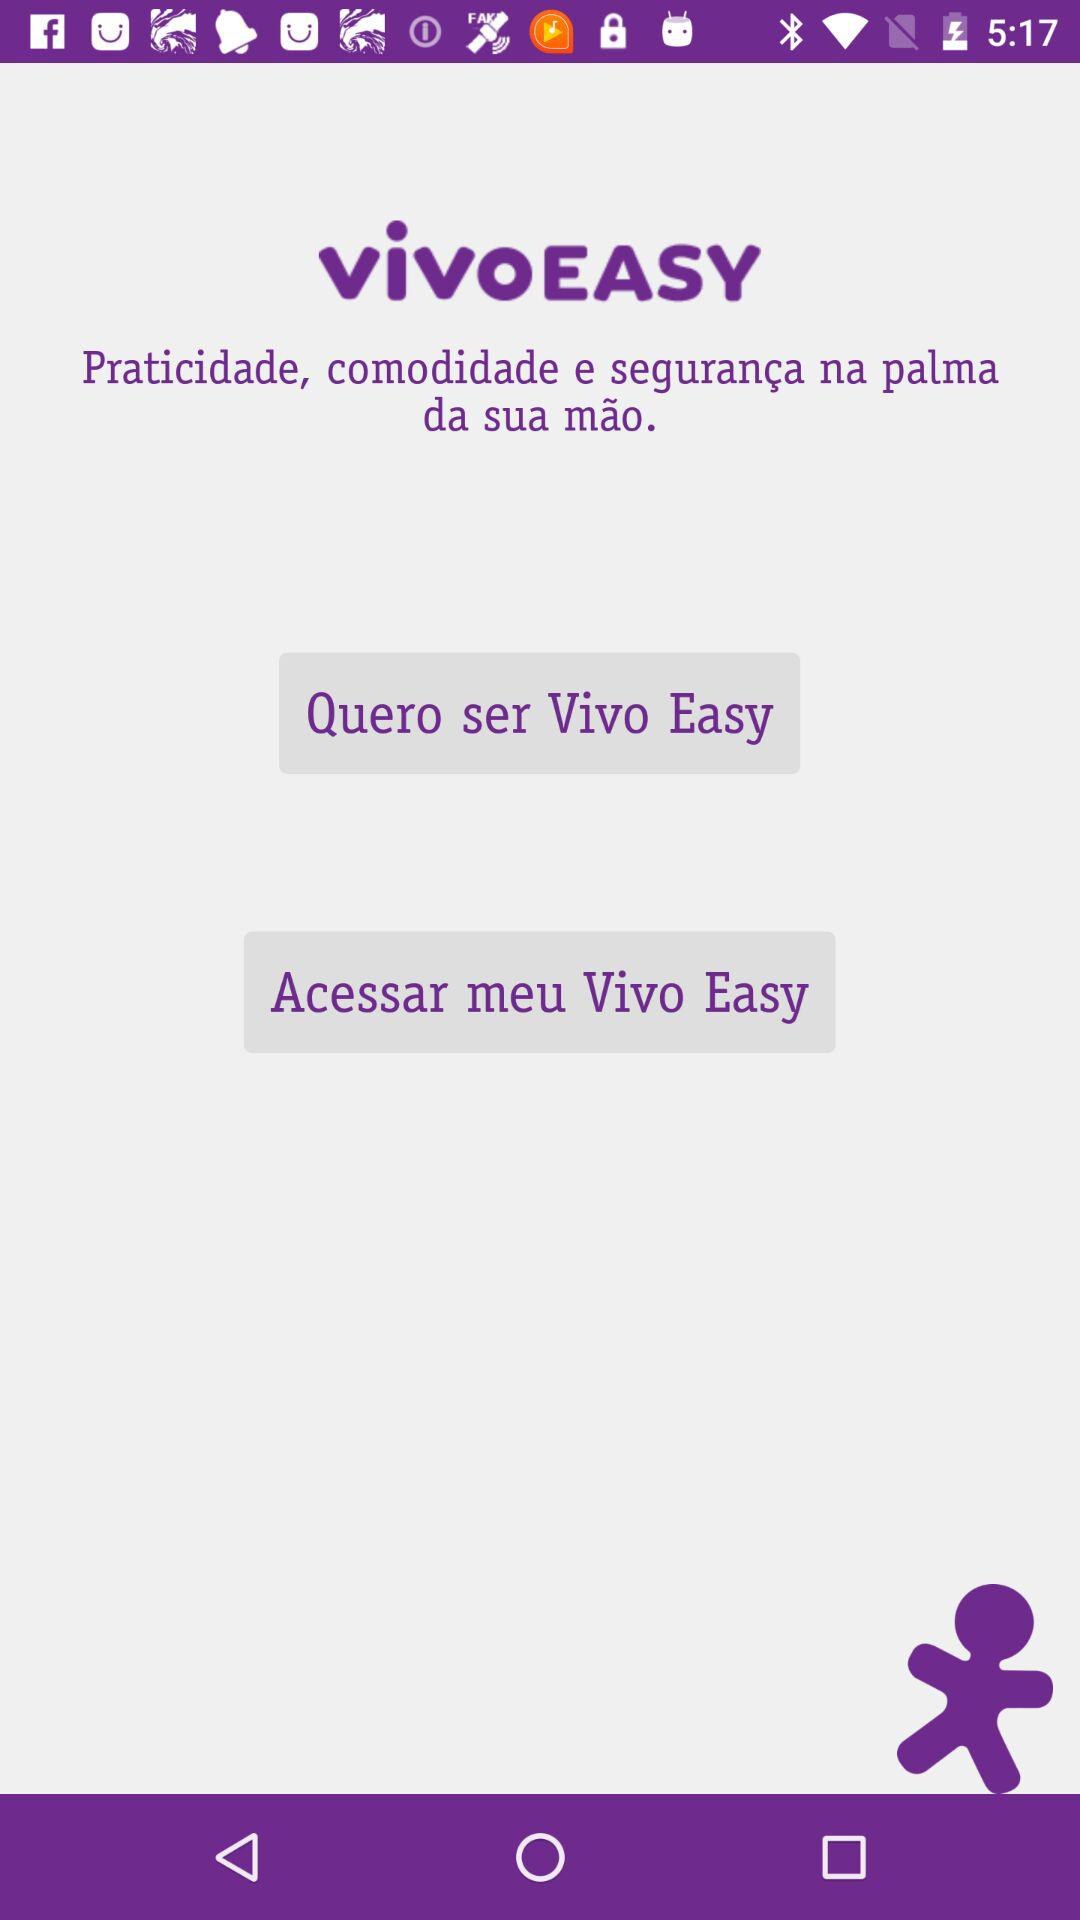What is the application name? The application name is "Vivo Easy". 